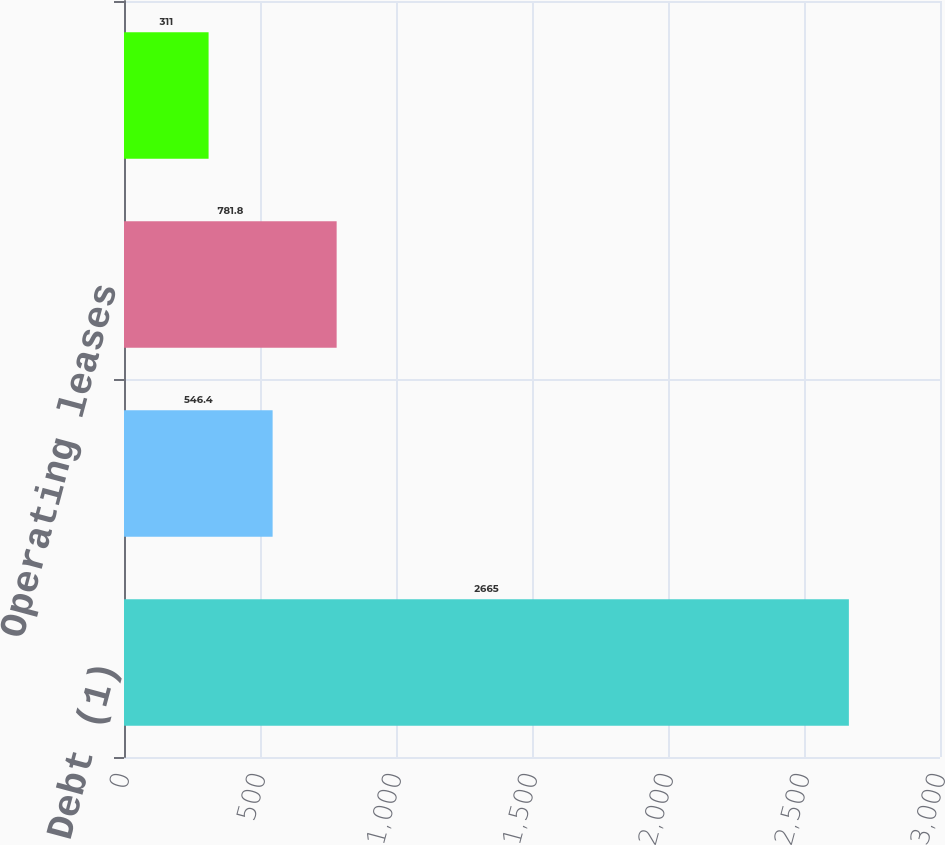Convert chart to OTSL. <chart><loc_0><loc_0><loc_500><loc_500><bar_chart><fcel>Debt (1)<fcel>Interest on fixed rate debt<fcel>Operating leases<fcel>Purchase obligations (3)<nl><fcel>2665<fcel>546.4<fcel>781.8<fcel>311<nl></chart> 